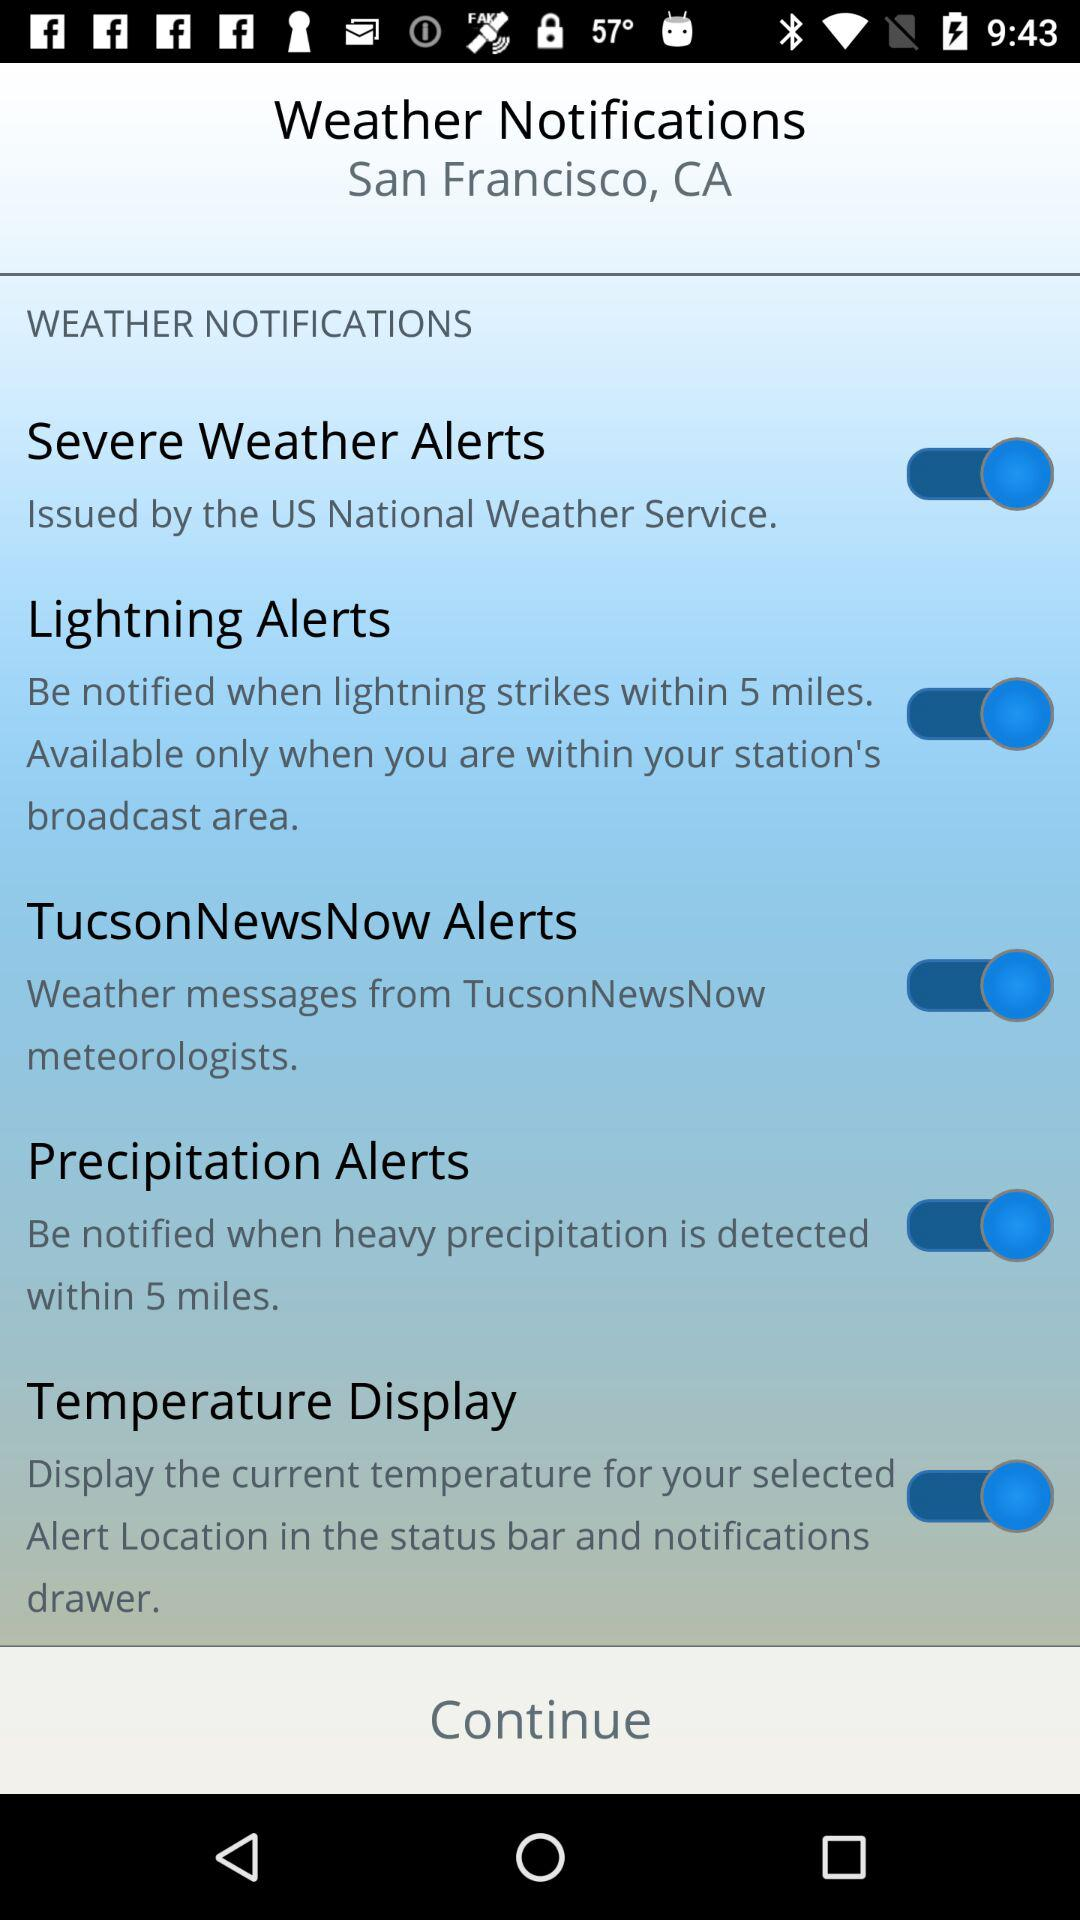What is the location of the weather notification? The location is San Francisco, CA. 